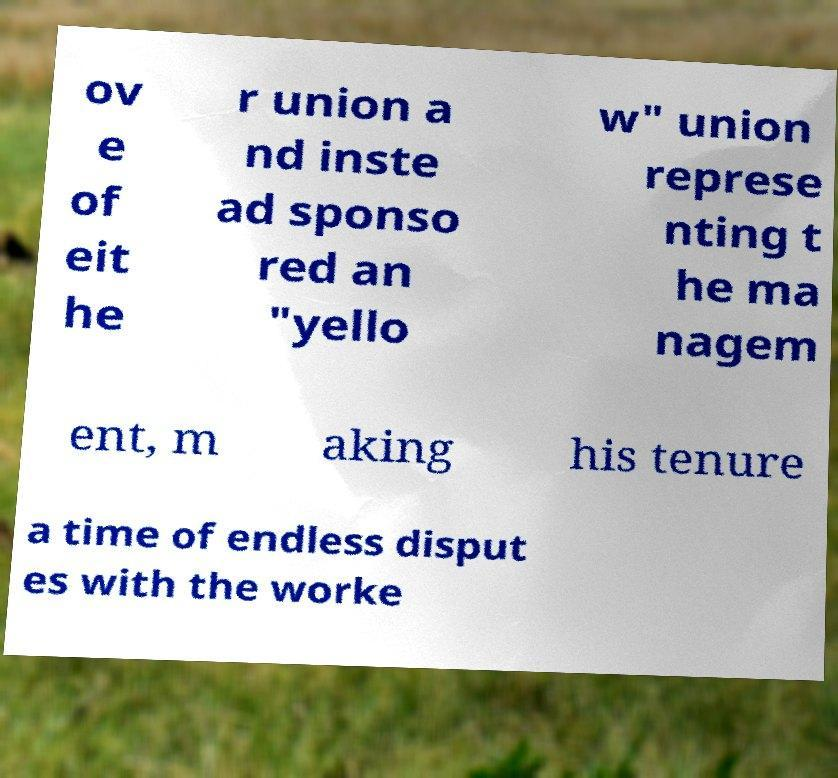Could you extract and type out the text from this image? ov e of eit he r union a nd inste ad sponso red an "yello w" union represe nting t he ma nagem ent, m aking his tenure a time of endless disput es with the worke 